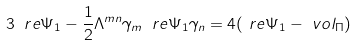<formula> <loc_0><loc_0><loc_500><loc_500>3 \ r e \Psi _ { 1 } - \frac { 1 } { 2 } \Lambda ^ { m n } \gamma _ { m } \ r e \Psi _ { 1 } \gamma _ { n } & = 4 ( \ r e \Psi _ { 1 } - \ v o l _ { \Pi } )</formula> 